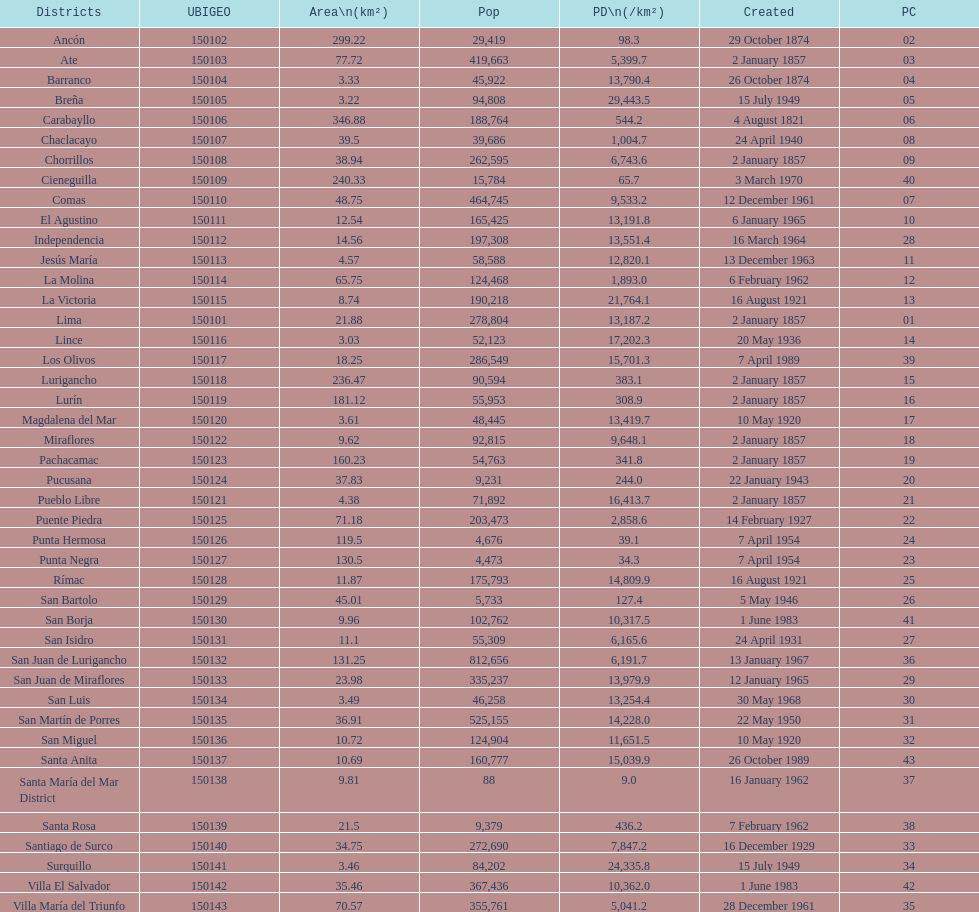How many districts are there in this city? 43. 